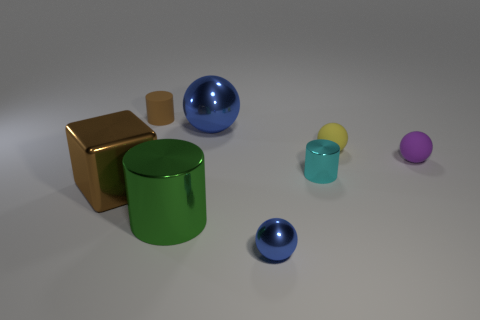There is a metal sphere that is the same size as the brown rubber cylinder; what color is it?
Give a very brief answer. Blue. There is a tiny metal cylinder; is it the same color as the thing left of the brown rubber thing?
Keep it short and to the point. No. The tiny cylinder to the right of the blue metal thing behind the yellow rubber ball is made of what material?
Give a very brief answer. Metal. What number of cylinders are to the right of the big blue metallic thing and in front of the large brown object?
Provide a short and direct response. 0. What number of other objects are there of the same size as the yellow matte ball?
Provide a succinct answer. 4. There is a blue object in front of the yellow ball; is its shape the same as the brown object that is in front of the cyan shiny cylinder?
Give a very brief answer. No. There is a brown metallic thing; are there any shiny balls in front of it?
Ensure brevity in your answer.  Yes. What color is the other rubber object that is the same shape as the tiny purple matte thing?
Provide a succinct answer. Yellow. Are there any other things that are the same shape as the large blue thing?
Offer a very short reply. Yes. There is a brown object to the right of the brown metallic object; what material is it?
Offer a very short reply. Rubber. 